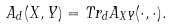<formula> <loc_0><loc_0><loc_500><loc_500>A _ { d } ( X , Y ) = T r _ { d } A _ { X Y } ( \cdot , \cdot ) .</formula> 